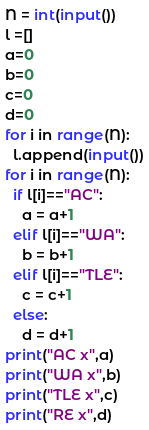Convert code to text. <code><loc_0><loc_0><loc_500><loc_500><_Python_>N = int(input())
l =[]
a=0
b=0
c=0
d=0
for i in range(N):
  l.append(input())
for i in range(N):
  if l[i]=="AC":
    a = a+1
  elif l[i]=="WA":
    b = b+1
  elif l[i]=="TLE":
    c = c+1
  else:
    d = d+1
print("AC x",a)
print("WA x",b)
print("TLE x",c)
print("RE x",d)
</code> 